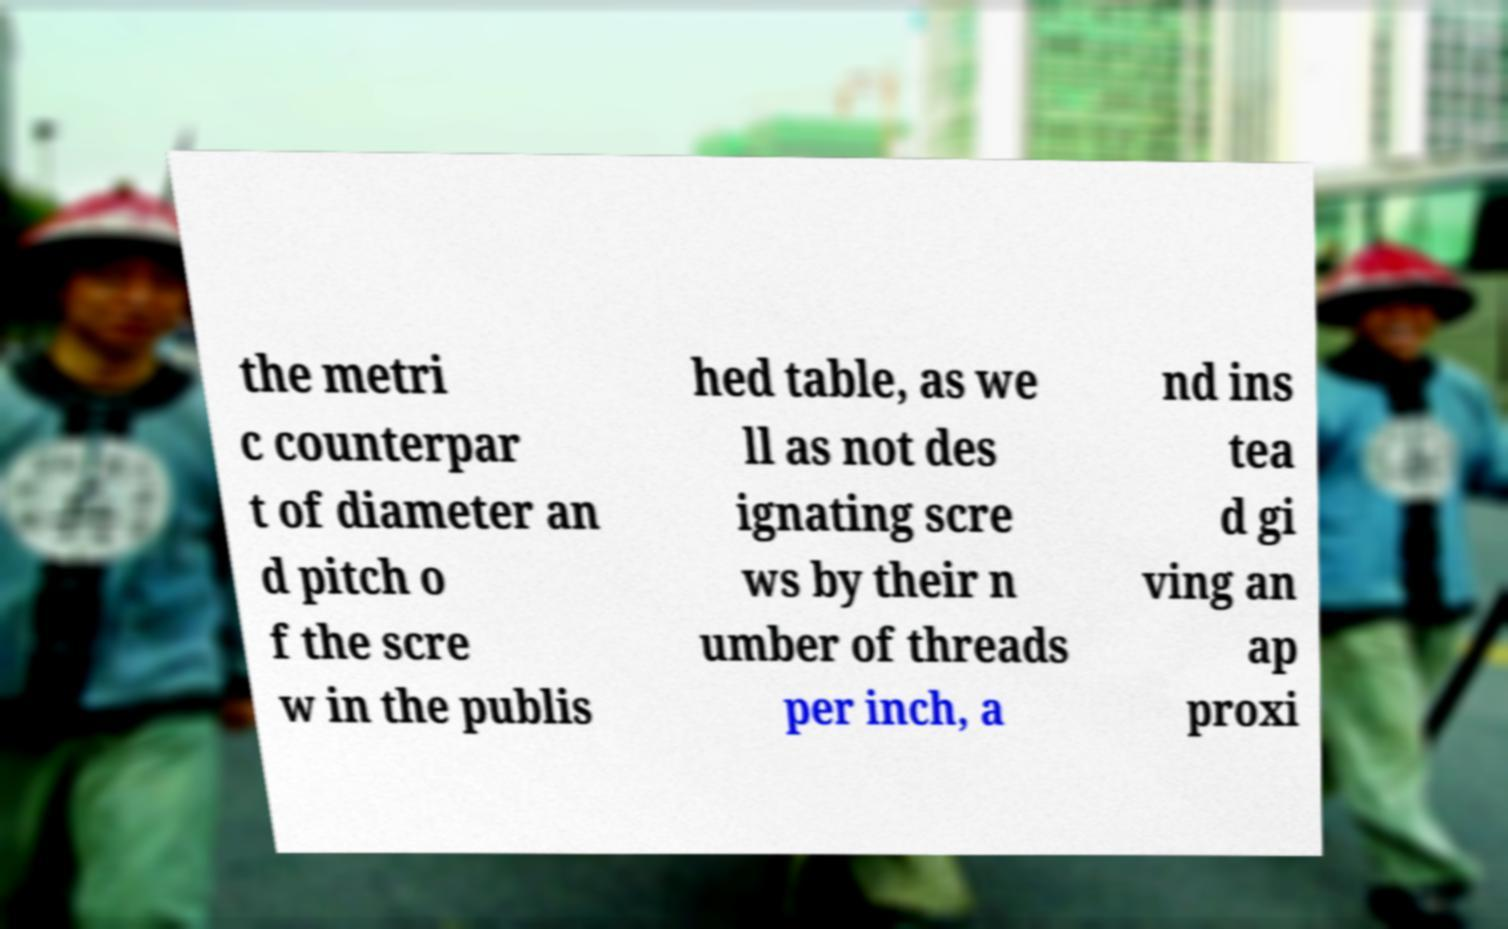I need the written content from this picture converted into text. Can you do that? the metri c counterpar t of diameter an d pitch o f the scre w in the publis hed table, as we ll as not des ignating scre ws by their n umber of threads per inch, a nd ins tea d gi ving an ap proxi 